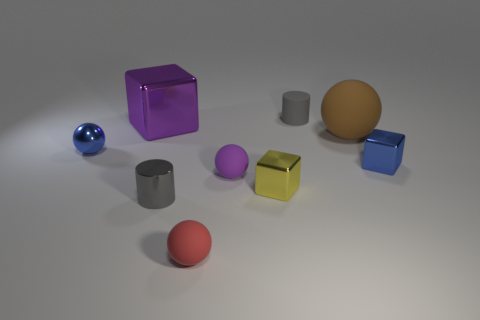Subtract 1 spheres. How many spheres are left? 3 Add 1 green shiny cubes. How many objects exist? 10 Subtract all balls. How many objects are left? 5 Add 3 purple metal cubes. How many purple metal cubes are left? 4 Add 7 small red objects. How many small red objects exist? 8 Subtract 1 red balls. How many objects are left? 8 Subtract all big red shiny spheres. Subtract all small blue metal objects. How many objects are left? 7 